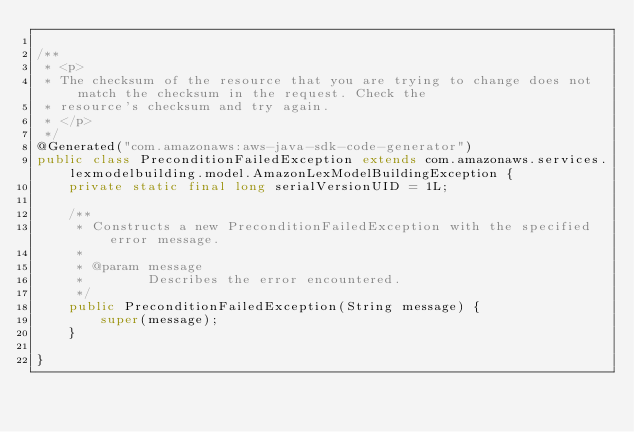Convert code to text. <code><loc_0><loc_0><loc_500><loc_500><_Java_>
/**
 * <p>
 * The checksum of the resource that you are trying to change does not match the checksum in the request. Check the
 * resource's checksum and try again.
 * </p>
 */
@Generated("com.amazonaws:aws-java-sdk-code-generator")
public class PreconditionFailedException extends com.amazonaws.services.lexmodelbuilding.model.AmazonLexModelBuildingException {
    private static final long serialVersionUID = 1L;

    /**
     * Constructs a new PreconditionFailedException with the specified error message.
     *
     * @param message
     *        Describes the error encountered.
     */
    public PreconditionFailedException(String message) {
        super(message);
    }

}
</code> 